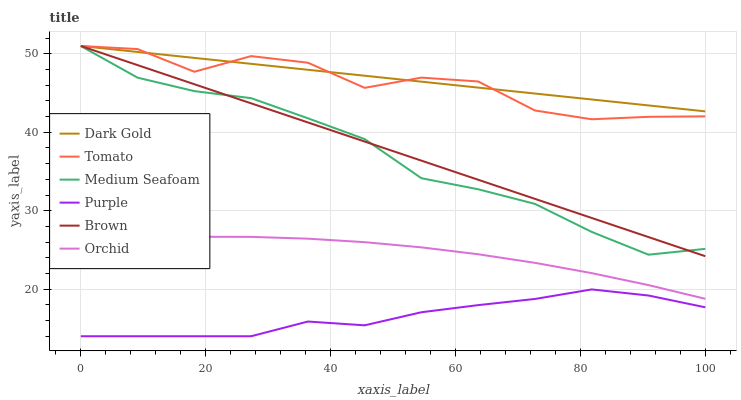Does Brown have the minimum area under the curve?
Answer yes or no. No. Does Brown have the maximum area under the curve?
Answer yes or no. No. Is Dark Gold the smoothest?
Answer yes or no. No. Is Dark Gold the roughest?
Answer yes or no. No. Does Brown have the lowest value?
Answer yes or no. No. Does Purple have the highest value?
Answer yes or no. No. Is Purple less than Medium Seafoam?
Answer yes or no. Yes. Is Medium Seafoam greater than Orchid?
Answer yes or no. Yes. Does Purple intersect Medium Seafoam?
Answer yes or no. No. 